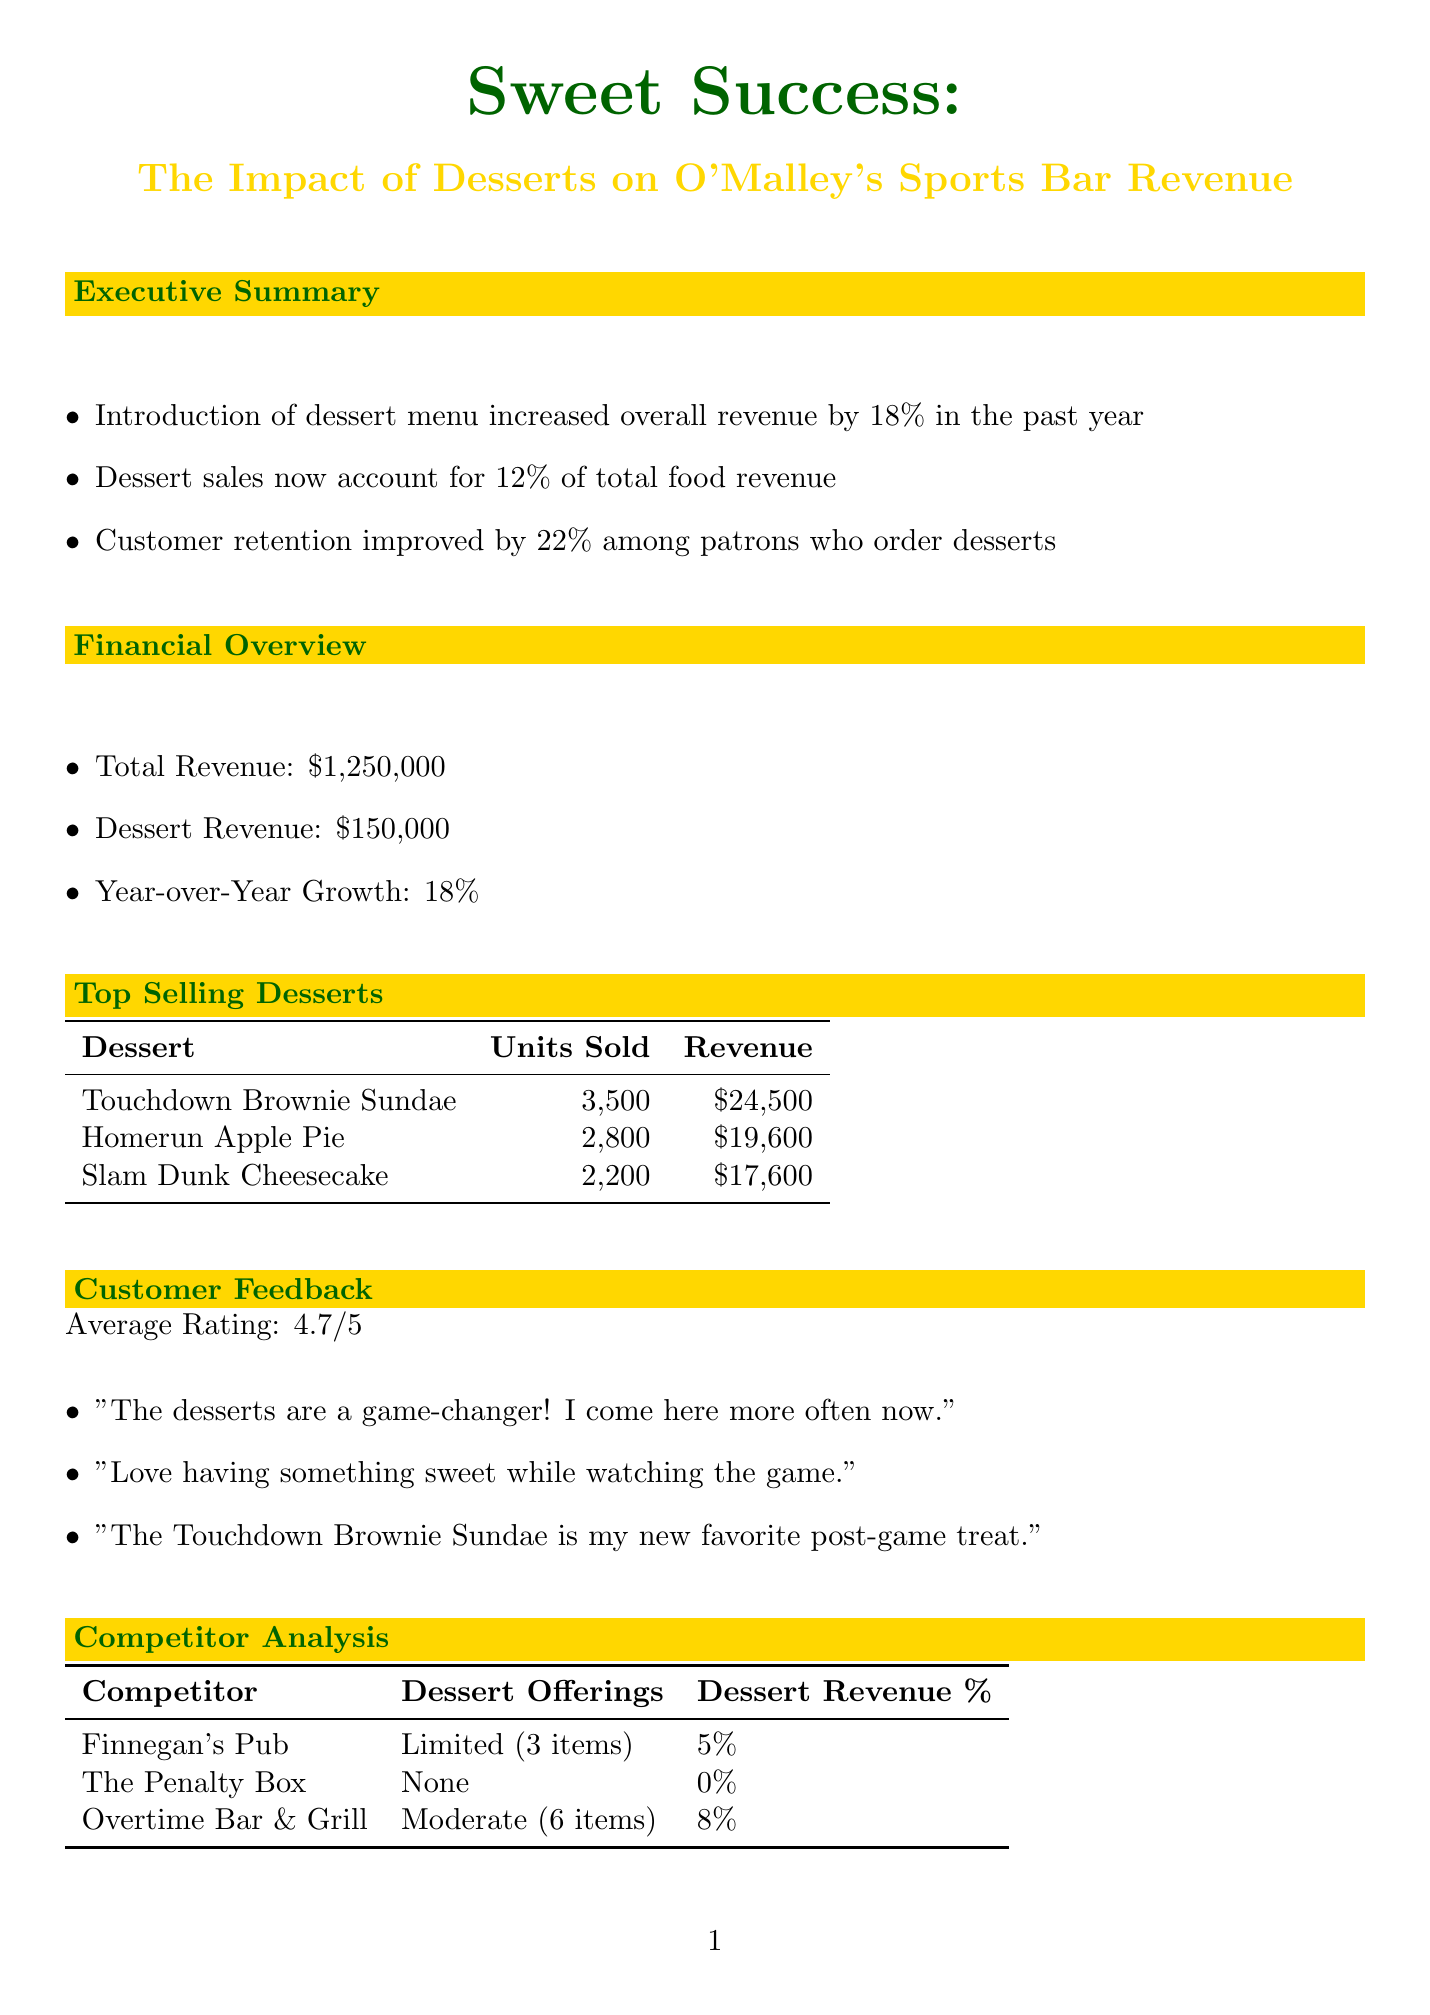What is the report title? The title of the report is stated at the beginning, and it is "Sweet Success: The Impact of Desserts on O'Malley's Sports Bar Revenue."
Answer: Sweet Success: The Impact of Desserts on O'Malley's Sports Bar Revenue What percentage of total food revenue do dessert sales account for? The document indicates that dessert sales now account for 12% of total food revenue.
Answer: 12% What was the total dessert revenue for the year? The financial overview section states that dessert revenue amounted to $150,000 for the year.
Answer: $150,000 Which dessert sold the most units? The top-selling desserts section provides a list, with the Touchdown Brownie Sundae being the highest at 3,500 units sold.
Answer: Touchdown Brownie Sundae What is the average customer rating for the desserts? Customer feedback shows that the average rating is 4.7 out of 5.
Answer: 4.7 Which competitor has the highest dessert revenue percentage? The competitor analysis indicates that Finnegan's Pub has a dessert revenue percentage of 5%, which is the highest among the listed competitors.
Answer: Finnegan's Pub What is one of the new dessert offerings planned for the future? The future plans section includes various new dessert offerings, one of which is sports-themed ice cream sundaes.
Answer: Sports-themed ice cream sundaes What type of loyalty promotion is planned? The future plans mention a loyalty program, which includes a free dessert after 10 visits.
Answer: Free dessert after 10 visits What is the conclusion about the dessert menu's impact? The conclusion summarizes that the dessert menu has significantly boosted revenue and customer satisfaction, which sets the establishment apart from competitors.
Answer: Boosted revenue and customer satisfaction 